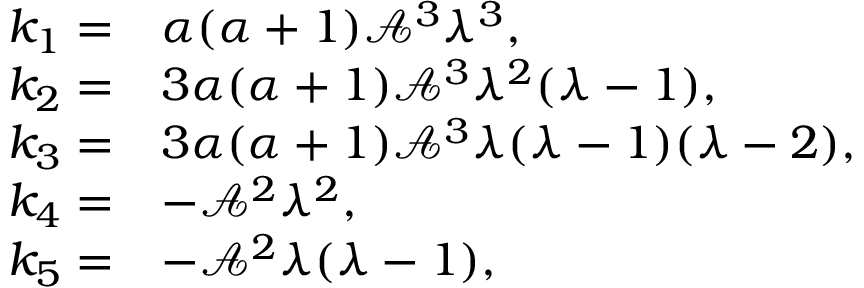Convert formula to latex. <formula><loc_0><loc_0><loc_500><loc_500>\begin{array} { r l } { k _ { 1 } = } & { \alpha ( \alpha + 1 ) \mathcal { A } ^ { 3 } \lambda ^ { 3 } , } \\ { k _ { 2 } = } & { 3 \alpha ( \alpha + 1 ) \mathcal { A } ^ { 3 } \lambda ^ { 2 } ( \lambda - 1 ) , } \\ { k _ { 3 } = } & { 3 \alpha ( \alpha + 1 ) \mathcal { A } ^ { 3 } \lambda ( \lambda - 1 ) ( \lambda - 2 ) , } \\ { k _ { 4 } = } & { - \mathcal { A } ^ { 2 } \lambda ^ { 2 } , } \\ { k _ { 5 } = } & { - \mathcal { A } ^ { 2 } \lambda ( \lambda - 1 ) , } \end{array}</formula> 